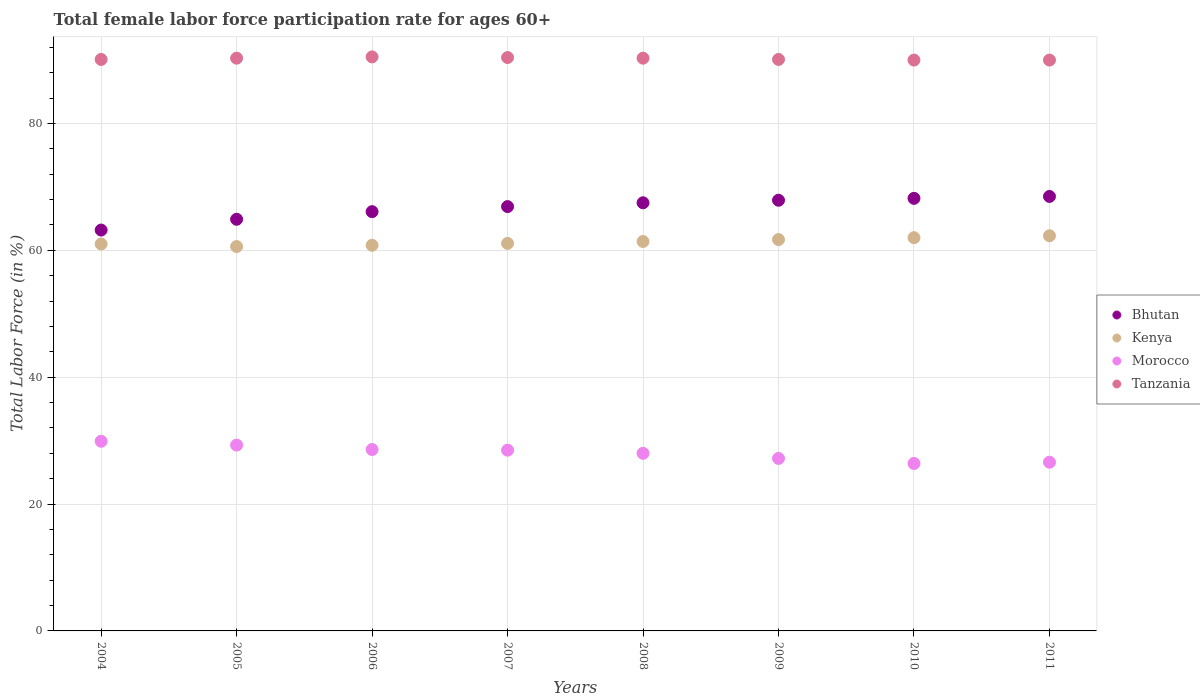Is the number of dotlines equal to the number of legend labels?
Your answer should be compact. Yes. What is the female labor force participation rate in Kenya in 2004?
Give a very brief answer. 61. Across all years, what is the maximum female labor force participation rate in Bhutan?
Offer a very short reply. 68.5. Across all years, what is the minimum female labor force participation rate in Bhutan?
Provide a succinct answer. 63.2. In which year was the female labor force participation rate in Tanzania minimum?
Provide a succinct answer. 2010. What is the total female labor force participation rate in Tanzania in the graph?
Your answer should be compact. 721.7. What is the difference between the female labor force participation rate in Bhutan in 2006 and that in 2010?
Keep it short and to the point. -2.1. What is the average female labor force participation rate in Bhutan per year?
Offer a terse response. 66.65. In the year 2007, what is the difference between the female labor force participation rate in Morocco and female labor force participation rate in Bhutan?
Your answer should be compact. -38.4. What is the ratio of the female labor force participation rate in Tanzania in 2004 to that in 2010?
Give a very brief answer. 1. Is the female labor force participation rate in Tanzania in 2009 less than that in 2010?
Ensure brevity in your answer.  No. What is the difference between the highest and the second highest female labor force participation rate in Bhutan?
Your answer should be very brief. 0.3. What is the difference between the highest and the lowest female labor force participation rate in Morocco?
Offer a terse response. 3.5. In how many years, is the female labor force participation rate in Tanzania greater than the average female labor force participation rate in Tanzania taken over all years?
Make the answer very short. 4. Is the sum of the female labor force participation rate in Bhutan in 2006 and 2011 greater than the maximum female labor force participation rate in Morocco across all years?
Your response must be concise. Yes. Does the female labor force participation rate in Kenya monotonically increase over the years?
Keep it short and to the point. No. Is the female labor force participation rate in Kenya strictly greater than the female labor force participation rate in Tanzania over the years?
Ensure brevity in your answer.  No. Is the female labor force participation rate in Tanzania strictly less than the female labor force participation rate in Morocco over the years?
Ensure brevity in your answer.  No. How many years are there in the graph?
Keep it short and to the point. 8. What is the difference between two consecutive major ticks on the Y-axis?
Provide a short and direct response. 20. Are the values on the major ticks of Y-axis written in scientific E-notation?
Provide a short and direct response. No. How are the legend labels stacked?
Your answer should be very brief. Vertical. What is the title of the graph?
Make the answer very short. Total female labor force participation rate for ages 60+. What is the label or title of the Y-axis?
Offer a very short reply. Total Labor Force (in %). What is the Total Labor Force (in %) of Bhutan in 2004?
Offer a terse response. 63.2. What is the Total Labor Force (in %) in Morocco in 2004?
Offer a very short reply. 29.9. What is the Total Labor Force (in %) in Tanzania in 2004?
Your answer should be compact. 90.1. What is the Total Labor Force (in %) of Bhutan in 2005?
Your response must be concise. 64.9. What is the Total Labor Force (in %) of Kenya in 2005?
Give a very brief answer. 60.6. What is the Total Labor Force (in %) of Morocco in 2005?
Keep it short and to the point. 29.3. What is the Total Labor Force (in %) of Tanzania in 2005?
Offer a terse response. 90.3. What is the Total Labor Force (in %) in Bhutan in 2006?
Your answer should be very brief. 66.1. What is the Total Labor Force (in %) in Kenya in 2006?
Ensure brevity in your answer.  60.8. What is the Total Labor Force (in %) of Morocco in 2006?
Keep it short and to the point. 28.6. What is the Total Labor Force (in %) in Tanzania in 2006?
Offer a very short reply. 90.5. What is the Total Labor Force (in %) in Bhutan in 2007?
Provide a short and direct response. 66.9. What is the Total Labor Force (in %) of Kenya in 2007?
Offer a terse response. 61.1. What is the Total Labor Force (in %) in Morocco in 2007?
Keep it short and to the point. 28.5. What is the Total Labor Force (in %) of Tanzania in 2007?
Ensure brevity in your answer.  90.4. What is the Total Labor Force (in %) of Bhutan in 2008?
Offer a very short reply. 67.5. What is the Total Labor Force (in %) of Kenya in 2008?
Your answer should be very brief. 61.4. What is the Total Labor Force (in %) in Tanzania in 2008?
Provide a succinct answer. 90.3. What is the Total Labor Force (in %) in Bhutan in 2009?
Ensure brevity in your answer.  67.9. What is the Total Labor Force (in %) of Kenya in 2009?
Provide a short and direct response. 61.7. What is the Total Labor Force (in %) in Morocco in 2009?
Your answer should be compact. 27.2. What is the Total Labor Force (in %) in Tanzania in 2009?
Provide a succinct answer. 90.1. What is the Total Labor Force (in %) in Bhutan in 2010?
Make the answer very short. 68.2. What is the Total Labor Force (in %) of Kenya in 2010?
Ensure brevity in your answer.  62. What is the Total Labor Force (in %) of Morocco in 2010?
Your response must be concise. 26.4. What is the Total Labor Force (in %) of Bhutan in 2011?
Offer a terse response. 68.5. What is the Total Labor Force (in %) of Kenya in 2011?
Your answer should be very brief. 62.3. What is the Total Labor Force (in %) of Morocco in 2011?
Offer a very short reply. 26.6. Across all years, what is the maximum Total Labor Force (in %) in Bhutan?
Provide a short and direct response. 68.5. Across all years, what is the maximum Total Labor Force (in %) of Kenya?
Your answer should be compact. 62.3. Across all years, what is the maximum Total Labor Force (in %) of Morocco?
Your answer should be compact. 29.9. Across all years, what is the maximum Total Labor Force (in %) of Tanzania?
Your answer should be compact. 90.5. Across all years, what is the minimum Total Labor Force (in %) of Bhutan?
Offer a terse response. 63.2. Across all years, what is the minimum Total Labor Force (in %) in Kenya?
Your response must be concise. 60.6. Across all years, what is the minimum Total Labor Force (in %) in Morocco?
Keep it short and to the point. 26.4. What is the total Total Labor Force (in %) of Bhutan in the graph?
Make the answer very short. 533.2. What is the total Total Labor Force (in %) in Kenya in the graph?
Offer a terse response. 490.9. What is the total Total Labor Force (in %) of Morocco in the graph?
Offer a terse response. 224.5. What is the total Total Labor Force (in %) in Tanzania in the graph?
Provide a short and direct response. 721.7. What is the difference between the Total Labor Force (in %) of Bhutan in 2004 and that in 2005?
Offer a very short reply. -1.7. What is the difference between the Total Labor Force (in %) of Bhutan in 2004 and that in 2006?
Offer a very short reply. -2.9. What is the difference between the Total Labor Force (in %) of Kenya in 2004 and that in 2007?
Make the answer very short. -0.1. What is the difference between the Total Labor Force (in %) in Tanzania in 2004 and that in 2007?
Provide a short and direct response. -0.3. What is the difference between the Total Labor Force (in %) of Kenya in 2004 and that in 2008?
Make the answer very short. -0.4. What is the difference between the Total Labor Force (in %) in Tanzania in 2004 and that in 2008?
Offer a terse response. -0.2. What is the difference between the Total Labor Force (in %) in Bhutan in 2004 and that in 2009?
Your response must be concise. -4.7. What is the difference between the Total Labor Force (in %) in Bhutan in 2004 and that in 2010?
Make the answer very short. -5. What is the difference between the Total Labor Force (in %) in Tanzania in 2004 and that in 2011?
Your answer should be compact. 0.1. What is the difference between the Total Labor Force (in %) of Kenya in 2005 and that in 2006?
Ensure brevity in your answer.  -0.2. What is the difference between the Total Labor Force (in %) in Tanzania in 2005 and that in 2006?
Keep it short and to the point. -0.2. What is the difference between the Total Labor Force (in %) in Kenya in 2005 and that in 2007?
Make the answer very short. -0.5. What is the difference between the Total Labor Force (in %) in Morocco in 2005 and that in 2007?
Provide a succinct answer. 0.8. What is the difference between the Total Labor Force (in %) of Tanzania in 2005 and that in 2007?
Provide a short and direct response. -0.1. What is the difference between the Total Labor Force (in %) in Kenya in 2005 and that in 2009?
Your answer should be compact. -1.1. What is the difference between the Total Labor Force (in %) in Morocco in 2005 and that in 2009?
Offer a very short reply. 2.1. What is the difference between the Total Labor Force (in %) in Bhutan in 2005 and that in 2010?
Keep it short and to the point. -3.3. What is the difference between the Total Labor Force (in %) of Tanzania in 2005 and that in 2010?
Provide a succinct answer. 0.3. What is the difference between the Total Labor Force (in %) in Morocco in 2005 and that in 2011?
Give a very brief answer. 2.7. What is the difference between the Total Labor Force (in %) in Tanzania in 2005 and that in 2011?
Keep it short and to the point. 0.3. What is the difference between the Total Labor Force (in %) of Morocco in 2006 and that in 2007?
Provide a succinct answer. 0.1. What is the difference between the Total Labor Force (in %) of Bhutan in 2006 and that in 2008?
Keep it short and to the point. -1.4. What is the difference between the Total Labor Force (in %) of Morocco in 2006 and that in 2008?
Your answer should be compact. 0.6. What is the difference between the Total Labor Force (in %) in Tanzania in 2006 and that in 2008?
Offer a terse response. 0.2. What is the difference between the Total Labor Force (in %) in Bhutan in 2006 and that in 2009?
Ensure brevity in your answer.  -1.8. What is the difference between the Total Labor Force (in %) in Kenya in 2006 and that in 2009?
Give a very brief answer. -0.9. What is the difference between the Total Labor Force (in %) of Tanzania in 2006 and that in 2009?
Ensure brevity in your answer.  0.4. What is the difference between the Total Labor Force (in %) of Bhutan in 2006 and that in 2010?
Ensure brevity in your answer.  -2.1. What is the difference between the Total Labor Force (in %) of Morocco in 2006 and that in 2010?
Offer a very short reply. 2.2. What is the difference between the Total Labor Force (in %) of Bhutan in 2006 and that in 2011?
Keep it short and to the point. -2.4. What is the difference between the Total Labor Force (in %) in Kenya in 2006 and that in 2011?
Your answer should be compact. -1.5. What is the difference between the Total Labor Force (in %) in Tanzania in 2006 and that in 2011?
Offer a terse response. 0.5. What is the difference between the Total Labor Force (in %) of Bhutan in 2007 and that in 2008?
Offer a very short reply. -0.6. What is the difference between the Total Labor Force (in %) in Kenya in 2007 and that in 2008?
Provide a short and direct response. -0.3. What is the difference between the Total Labor Force (in %) of Tanzania in 2007 and that in 2008?
Offer a terse response. 0.1. What is the difference between the Total Labor Force (in %) of Bhutan in 2007 and that in 2010?
Offer a very short reply. -1.3. What is the difference between the Total Labor Force (in %) in Kenya in 2007 and that in 2010?
Ensure brevity in your answer.  -0.9. What is the difference between the Total Labor Force (in %) of Morocco in 2007 and that in 2010?
Offer a terse response. 2.1. What is the difference between the Total Labor Force (in %) of Bhutan in 2007 and that in 2011?
Your answer should be very brief. -1.6. What is the difference between the Total Labor Force (in %) in Kenya in 2007 and that in 2011?
Make the answer very short. -1.2. What is the difference between the Total Labor Force (in %) in Morocco in 2007 and that in 2011?
Provide a short and direct response. 1.9. What is the difference between the Total Labor Force (in %) of Tanzania in 2007 and that in 2011?
Offer a terse response. 0.4. What is the difference between the Total Labor Force (in %) in Kenya in 2008 and that in 2009?
Keep it short and to the point. -0.3. What is the difference between the Total Labor Force (in %) in Tanzania in 2008 and that in 2009?
Offer a terse response. 0.2. What is the difference between the Total Labor Force (in %) in Bhutan in 2008 and that in 2010?
Keep it short and to the point. -0.7. What is the difference between the Total Labor Force (in %) of Morocco in 2008 and that in 2010?
Provide a succinct answer. 1.6. What is the difference between the Total Labor Force (in %) of Tanzania in 2008 and that in 2010?
Make the answer very short. 0.3. What is the difference between the Total Labor Force (in %) in Morocco in 2008 and that in 2011?
Your response must be concise. 1.4. What is the difference between the Total Labor Force (in %) in Bhutan in 2009 and that in 2010?
Provide a short and direct response. -0.3. What is the difference between the Total Labor Force (in %) of Kenya in 2009 and that in 2010?
Offer a terse response. -0.3. What is the difference between the Total Labor Force (in %) of Bhutan in 2009 and that in 2011?
Offer a very short reply. -0.6. What is the difference between the Total Labor Force (in %) of Kenya in 2009 and that in 2011?
Offer a terse response. -0.6. What is the difference between the Total Labor Force (in %) in Tanzania in 2009 and that in 2011?
Give a very brief answer. 0.1. What is the difference between the Total Labor Force (in %) of Bhutan in 2010 and that in 2011?
Provide a succinct answer. -0.3. What is the difference between the Total Labor Force (in %) in Morocco in 2010 and that in 2011?
Provide a short and direct response. -0.2. What is the difference between the Total Labor Force (in %) in Tanzania in 2010 and that in 2011?
Offer a very short reply. 0. What is the difference between the Total Labor Force (in %) of Bhutan in 2004 and the Total Labor Force (in %) of Kenya in 2005?
Your answer should be compact. 2.6. What is the difference between the Total Labor Force (in %) of Bhutan in 2004 and the Total Labor Force (in %) of Morocco in 2005?
Give a very brief answer. 33.9. What is the difference between the Total Labor Force (in %) of Bhutan in 2004 and the Total Labor Force (in %) of Tanzania in 2005?
Your response must be concise. -27.1. What is the difference between the Total Labor Force (in %) of Kenya in 2004 and the Total Labor Force (in %) of Morocco in 2005?
Your answer should be very brief. 31.7. What is the difference between the Total Labor Force (in %) in Kenya in 2004 and the Total Labor Force (in %) in Tanzania in 2005?
Offer a very short reply. -29.3. What is the difference between the Total Labor Force (in %) of Morocco in 2004 and the Total Labor Force (in %) of Tanzania in 2005?
Offer a terse response. -60.4. What is the difference between the Total Labor Force (in %) of Bhutan in 2004 and the Total Labor Force (in %) of Morocco in 2006?
Your answer should be very brief. 34.6. What is the difference between the Total Labor Force (in %) of Bhutan in 2004 and the Total Labor Force (in %) of Tanzania in 2006?
Your response must be concise. -27.3. What is the difference between the Total Labor Force (in %) in Kenya in 2004 and the Total Labor Force (in %) in Morocco in 2006?
Your answer should be very brief. 32.4. What is the difference between the Total Labor Force (in %) in Kenya in 2004 and the Total Labor Force (in %) in Tanzania in 2006?
Keep it short and to the point. -29.5. What is the difference between the Total Labor Force (in %) in Morocco in 2004 and the Total Labor Force (in %) in Tanzania in 2006?
Ensure brevity in your answer.  -60.6. What is the difference between the Total Labor Force (in %) of Bhutan in 2004 and the Total Labor Force (in %) of Morocco in 2007?
Provide a short and direct response. 34.7. What is the difference between the Total Labor Force (in %) in Bhutan in 2004 and the Total Labor Force (in %) in Tanzania in 2007?
Ensure brevity in your answer.  -27.2. What is the difference between the Total Labor Force (in %) in Kenya in 2004 and the Total Labor Force (in %) in Morocco in 2007?
Provide a short and direct response. 32.5. What is the difference between the Total Labor Force (in %) in Kenya in 2004 and the Total Labor Force (in %) in Tanzania in 2007?
Give a very brief answer. -29.4. What is the difference between the Total Labor Force (in %) in Morocco in 2004 and the Total Labor Force (in %) in Tanzania in 2007?
Keep it short and to the point. -60.5. What is the difference between the Total Labor Force (in %) of Bhutan in 2004 and the Total Labor Force (in %) of Kenya in 2008?
Make the answer very short. 1.8. What is the difference between the Total Labor Force (in %) of Bhutan in 2004 and the Total Labor Force (in %) of Morocco in 2008?
Keep it short and to the point. 35.2. What is the difference between the Total Labor Force (in %) of Bhutan in 2004 and the Total Labor Force (in %) of Tanzania in 2008?
Make the answer very short. -27.1. What is the difference between the Total Labor Force (in %) of Kenya in 2004 and the Total Labor Force (in %) of Tanzania in 2008?
Offer a terse response. -29.3. What is the difference between the Total Labor Force (in %) in Morocco in 2004 and the Total Labor Force (in %) in Tanzania in 2008?
Make the answer very short. -60.4. What is the difference between the Total Labor Force (in %) in Bhutan in 2004 and the Total Labor Force (in %) in Kenya in 2009?
Your answer should be very brief. 1.5. What is the difference between the Total Labor Force (in %) in Bhutan in 2004 and the Total Labor Force (in %) in Morocco in 2009?
Your answer should be compact. 36. What is the difference between the Total Labor Force (in %) in Bhutan in 2004 and the Total Labor Force (in %) in Tanzania in 2009?
Offer a terse response. -26.9. What is the difference between the Total Labor Force (in %) in Kenya in 2004 and the Total Labor Force (in %) in Morocco in 2009?
Your response must be concise. 33.8. What is the difference between the Total Labor Force (in %) of Kenya in 2004 and the Total Labor Force (in %) of Tanzania in 2009?
Provide a short and direct response. -29.1. What is the difference between the Total Labor Force (in %) in Morocco in 2004 and the Total Labor Force (in %) in Tanzania in 2009?
Your answer should be very brief. -60.2. What is the difference between the Total Labor Force (in %) in Bhutan in 2004 and the Total Labor Force (in %) in Kenya in 2010?
Offer a terse response. 1.2. What is the difference between the Total Labor Force (in %) of Bhutan in 2004 and the Total Labor Force (in %) of Morocco in 2010?
Your answer should be very brief. 36.8. What is the difference between the Total Labor Force (in %) in Bhutan in 2004 and the Total Labor Force (in %) in Tanzania in 2010?
Offer a very short reply. -26.8. What is the difference between the Total Labor Force (in %) in Kenya in 2004 and the Total Labor Force (in %) in Morocco in 2010?
Offer a terse response. 34.6. What is the difference between the Total Labor Force (in %) of Kenya in 2004 and the Total Labor Force (in %) of Tanzania in 2010?
Offer a terse response. -29. What is the difference between the Total Labor Force (in %) in Morocco in 2004 and the Total Labor Force (in %) in Tanzania in 2010?
Give a very brief answer. -60.1. What is the difference between the Total Labor Force (in %) of Bhutan in 2004 and the Total Labor Force (in %) of Morocco in 2011?
Make the answer very short. 36.6. What is the difference between the Total Labor Force (in %) of Bhutan in 2004 and the Total Labor Force (in %) of Tanzania in 2011?
Your answer should be very brief. -26.8. What is the difference between the Total Labor Force (in %) in Kenya in 2004 and the Total Labor Force (in %) in Morocco in 2011?
Give a very brief answer. 34.4. What is the difference between the Total Labor Force (in %) in Kenya in 2004 and the Total Labor Force (in %) in Tanzania in 2011?
Your answer should be very brief. -29. What is the difference between the Total Labor Force (in %) of Morocco in 2004 and the Total Labor Force (in %) of Tanzania in 2011?
Give a very brief answer. -60.1. What is the difference between the Total Labor Force (in %) in Bhutan in 2005 and the Total Labor Force (in %) in Kenya in 2006?
Make the answer very short. 4.1. What is the difference between the Total Labor Force (in %) in Bhutan in 2005 and the Total Labor Force (in %) in Morocco in 2006?
Your answer should be very brief. 36.3. What is the difference between the Total Labor Force (in %) of Bhutan in 2005 and the Total Labor Force (in %) of Tanzania in 2006?
Offer a terse response. -25.6. What is the difference between the Total Labor Force (in %) in Kenya in 2005 and the Total Labor Force (in %) in Tanzania in 2006?
Your answer should be compact. -29.9. What is the difference between the Total Labor Force (in %) of Morocco in 2005 and the Total Labor Force (in %) of Tanzania in 2006?
Keep it short and to the point. -61.2. What is the difference between the Total Labor Force (in %) of Bhutan in 2005 and the Total Labor Force (in %) of Kenya in 2007?
Ensure brevity in your answer.  3.8. What is the difference between the Total Labor Force (in %) in Bhutan in 2005 and the Total Labor Force (in %) in Morocco in 2007?
Give a very brief answer. 36.4. What is the difference between the Total Labor Force (in %) of Bhutan in 2005 and the Total Labor Force (in %) of Tanzania in 2007?
Your answer should be very brief. -25.5. What is the difference between the Total Labor Force (in %) of Kenya in 2005 and the Total Labor Force (in %) of Morocco in 2007?
Make the answer very short. 32.1. What is the difference between the Total Labor Force (in %) of Kenya in 2005 and the Total Labor Force (in %) of Tanzania in 2007?
Offer a terse response. -29.8. What is the difference between the Total Labor Force (in %) in Morocco in 2005 and the Total Labor Force (in %) in Tanzania in 2007?
Offer a very short reply. -61.1. What is the difference between the Total Labor Force (in %) of Bhutan in 2005 and the Total Labor Force (in %) of Morocco in 2008?
Your answer should be very brief. 36.9. What is the difference between the Total Labor Force (in %) of Bhutan in 2005 and the Total Labor Force (in %) of Tanzania in 2008?
Your answer should be very brief. -25.4. What is the difference between the Total Labor Force (in %) in Kenya in 2005 and the Total Labor Force (in %) in Morocco in 2008?
Make the answer very short. 32.6. What is the difference between the Total Labor Force (in %) in Kenya in 2005 and the Total Labor Force (in %) in Tanzania in 2008?
Offer a terse response. -29.7. What is the difference between the Total Labor Force (in %) of Morocco in 2005 and the Total Labor Force (in %) of Tanzania in 2008?
Your answer should be very brief. -61. What is the difference between the Total Labor Force (in %) of Bhutan in 2005 and the Total Labor Force (in %) of Kenya in 2009?
Offer a very short reply. 3.2. What is the difference between the Total Labor Force (in %) in Bhutan in 2005 and the Total Labor Force (in %) in Morocco in 2009?
Offer a very short reply. 37.7. What is the difference between the Total Labor Force (in %) of Bhutan in 2005 and the Total Labor Force (in %) of Tanzania in 2009?
Your response must be concise. -25.2. What is the difference between the Total Labor Force (in %) in Kenya in 2005 and the Total Labor Force (in %) in Morocco in 2009?
Provide a short and direct response. 33.4. What is the difference between the Total Labor Force (in %) of Kenya in 2005 and the Total Labor Force (in %) of Tanzania in 2009?
Offer a terse response. -29.5. What is the difference between the Total Labor Force (in %) of Morocco in 2005 and the Total Labor Force (in %) of Tanzania in 2009?
Make the answer very short. -60.8. What is the difference between the Total Labor Force (in %) of Bhutan in 2005 and the Total Labor Force (in %) of Kenya in 2010?
Offer a very short reply. 2.9. What is the difference between the Total Labor Force (in %) of Bhutan in 2005 and the Total Labor Force (in %) of Morocco in 2010?
Your answer should be very brief. 38.5. What is the difference between the Total Labor Force (in %) in Bhutan in 2005 and the Total Labor Force (in %) in Tanzania in 2010?
Make the answer very short. -25.1. What is the difference between the Total Labor Force (in %) in Kenya in 2005 and the Total Labor Force (in %) in Morocco in 2010?
Make the answer very short. 34.2. What is the difference between the Total Labor Force (in %) of Kenya in 2005 and the Total Labor Force (in %) of Tanzania in 2010?
Make the answer very short. -29.4. What is the difference between the Total Labor Force (in %) of Morocco in 2005 and the Total Labor Force (in %) of Tanzania in 2010?
Ensure brevity in your answer.  -60.7. What is the difference between the Total Labor Force (in %) of Bhutan in 2005 and the Total Labor Force (in %) of Morocco in 2011?
Your answer should be compact. 38.3. What is the difference between the Total Labor Force (in %) of Bhutan in 2005 and the Total Labor Force (in %) of Tanzania in 2011?
Offer a very short reply. -25.1. What is the difference between the Total Labor Force (in %) in Kenya in 2005 and the Total Labor Force (in %) in Morocco in 2011?
Give a very brief answer. 34. What is the difference between the Total Labor Force (in %) in Kenya in 2005 and the Total Labor Force (in %) in Tanzania in 2011?
Make the answer very short. -29.4. What is the difference between the Total Labor Force (in %) in Morocco in 2005 and the Total Labor Force (in %) in Tanzania in 2011?
Keep it short and to the point. -60.7. What is the difference between the Total Labor Force (in %) in Bhutan in 2006 and the Total Labor Force (in %) in Morocco in 2007?
Offer a very short reply. 37.6. What is the difference between the Total Labor Force (in %) of Bhutan in 2006 and the Total Labor Force (in %) of Tanzania in 2007?
Offer a very short reply. -24.3. What is the difference between the Total Labor Force (in %) of Kenya in 2006 and the Total Labor Force (in %) of Morocco in 2007?
Offer a very short reply. 32.3. What is the difference between the Total Labor Force (in %) of Kenya in 2006 and the Total Labor Force (in %) of Tanzania in 2007?
Give a very brief answer. -29.6. What is the difference between the Total Labor Force (in %) in Morocco in 2006 and the Total Labor Force (in %) in Tanzania in 2007?
Make the answer very short. -61.8. What is the difference between the Total Labor Force (in %) of Bhutan in 2006 and the Total Labor Force (in %) of Morocco in 2008?
Your response must be concise. 38.1. What is the difference between the Total Labor Force (in %) in Bhutan in 2006 and the Total Labor Force (in %) in Tanzania in 2008?
Keep it short and to the point. -24.2. What is the difference between the Total Labor Force (in %) of Kenya in 2006 and the Total Labor Force (in %) of Morocco in 2008?
Keep it short and to the point. 32.8. What is the difference between the Total Labor Force (in %) of Kenya in 2006 and the Total Labor Force (in %) of Tanzania in 2008?
Offer a very short reply. -29.5. What is the difference between the Total Labor Force (in %) of Morocco in 2006 and the Total Labor Force (in %) of Tanzania in 2008?
Provide a succinct answer. -61.7. What is the difference between the Total Labor Force (in %) in Bhutan in 2006 and the Total Labor Force (in %) in Kenya in 2009?
Make the answer very short. 4.4. What is the difference between the Total Labor Force (in %) of Bhutan in 2006 and the Total Labor Force (in %) of Morocco in 2009?
Ensure brevity in your answer.  38.9. What is the difference between the Total Labor Force (in %) of Kenya in 2006 and the Total Labor Force (in %) of Morocco in 2009?
Keep it short and to the point. 33.6. What is the difference between the Total Labor Force (in %) of Kenya in 2006 and the Total Labor Force (in %) of Tanzania in 2009?
Your response must be concise. -29.3. What is the difference between the Total Labor Force (in %) in Morocco in 2006 and the Total Labor Force (in %) in Tanzania in 2009?
Your answer should be compact. -61.5. What is the difference between the Total Labor Force (in %) in Bhutan in 2006 and the Total Labor Force (in %) in Morocco in 2010?
Make the answer very short. 39.7. What is the difference between the Total Labor Force (in %) in Bhutan in 2006 and the Total Labor Force (in %) in Tanzania in 2010?
Keep it short and to the point. -23.9. What is the difference between the Total Labor Force (in %) in Kenya in 2006 and the Total Labor Force (in %) in Morocco in 2010?
Provide a succinct answer. 34.4. What is the difference between the Total Labor Force (in %) in Kenya in 2006 and the Total Labor Force (in %) in Tanzania in 2010?
Offer a very short reply. -29.2. What is the difference between the Total Labor Force (in %) of Morocco in 2006 and the Total Labor Force (in %) of Tanzania in 2010?
Your response must be concise. -61.4. What is the difference between the Total Labor Force (in %) of Bhutan in 2006 and the Total Labor Force (in %) of Kenya in 2011?
Offer a terse response. 3.8. What is the difference between the Total Labor Force (in %) of Bhutan in 2006 and the Total Labor Force (in %) of Morocco in 2011?
Offer a terse response. 39.5. What is the difference between the Total Labor Force (in %) in Bhutan in 2006 and the Total Labor Force (in %) in Tanzania in 2011?
Your answer should be very brief. -23.9. What is the difference between the Total Labor Force (in %) in Kenya in 2006 and the Total Labor Force (in %) in Morocco in 2011?
Provide a short and direct response. 34.2. What is the difference between the Total Labor Force (in %) in Kenya in 2006 and the Total Labor Force (in %) in Tanzania in 2011?
Make the answer very short. -29.2. What is the difference between the Total Labor Force (in %) in Morocco in 2006 and the Total Labor Force (in %) in Tanzania in 2011?
Offer a terse response. -61.4. What is the difference between the Total Labor Force (in %) in Bhutan in 2007 and the Total Labor Force (in %) in Morocco in 2008?
Your answer should be compact. 38.9. What is the difference between the Total Labor Force (in %) of Bhutan in 2007 and the Total Labor Force (in %) of Tanzania in 2008?
Your response must be concise. -23.4. What is the difference between the Total Labor Force (in %) of Kenya in 2007 and the Total Labor Force (in %) of Morocco in 2008?
Provide a short and direct response. 33.1. What is the difference between the Total Labor Force (in %) of Kenya in 2007 and the Total Labor Force (in %) of Tanzania in 2008?
Your response must be concise. -29.2. What is the difference between the Total Labor Force (in %) in Morocco in 2007 and the Total Labor Force (in %) in Tanzania in 2008?
Your answer should be very brief. -61.8. What is the difference between the Total Labor Force (in %) in Bhutan in 2007 and the Total Labor Force (in %) in Morocco in 2009?
Your response must be concise. 39.7. What is the difference between the Total Labor Force (in %) in Bhutan in 2007 and the Total Labor Force (in %) in Tanzania in 2009?
Keep it short and to the point. -23.2. What is the difference between the Total Labor Force (in %) in Kenya in 2007 and the Total Labor Force (in %) in Morocco in 2009?
Your answer should be compact. 33.9. What is the difference between the Total Labor Force (in %) in Kenya in 2007 and the Total Labor Force (in %) in Tanzania in 2009?
Provide a short and direct response. -29. What is the difference between the Total Labor Force (in %) of Morocco in 2007 and the Total Labor Force (in %) of Tanzania in 2009?
Give a very brief answer. -61.6. What is the difference between the Total Labor Force (in %) of Bhutan in 2007 and the Total Labor Force (in %) of Morocco in 2010?
Give a very brief answer. 40.5. What is the difference between the Total Labor Force (in %) in Bhutan in 2007 and the Total Labor Force (in %) in Tanzania in 2010?
Your answer should be very brief. -23.1. What is the difference between the Total Labor Force (in %) of Kenya in 2007 and the Total Labor Force (in %) of Morocco in 2010?
Make the answer very short. 34.7. What is the difference between the Total Labor Force (in %) of Kenya in 2007 and the Total Labor Force (in %) of Tanzania in 2010?
Your answer should be very brief. -28.9. What is the difference between the Total Labor Force (in %) of Morocco in 2007 and the Total Labor Force (in %) of Tanzania in 2010?
Your answer should be very brief. -61.5. What is the difference between the Total Labor Force (in %) in Bhutan in 2007 and the Total Labor Force (in %) in Kenya in 2011?
Your answer should be very brief. 4.6. What is the difference between the Total Labor Force (in %) in Bhutan in 2007 and the Total Labor Force (in %) in Morocco in 2011?
Provide a succinct answer. 40.3. What is the difference between the Total Labor Force (in %) of Bhutan in 2007 and the Total Labor Force (in %) of Tanzania in 2011?
Your response must be concise. -23.1. What is the difference between the Total Labor Force (in %) of Kenya in 2007 and the Total Labor Force (in %) of Morocco in 2011?
Offer a terse response. 34.5. What is the difference between the Total Labor Force (in %) in Kenya in 2007 and the Total Labor Force (in %) in Tanzania in 2011?
Provide a succinct answer. -28.9. What is the difference between the Total Labor Force (in %) in Morocco in 2007 and the Total Labor Force (in %) in Tanzania in 2011?
Your answer should be compact. -61.5. What is the difference between the Total Labor Force (in %) in Bhutan in 2008 and the Total Labor Force (in %) in Kenya in 2009?
Make the answer very short. 5.8. What is the difference between the Total Labor Force (in %) in Bhutan in 2008 and the Total Labor Force (in %) in Morocco in 2009?
Offer a terse response. 40.3. What is the difference between the Total Labor Force (in %) in Bhutan in 2008 and the Total Labor Force (in %) in Tanzania in 2009?
Offer a very short reply. -22.6. What is the difference between the Total Labor Force (in %) of Kenya in 2008 and the Total Labor Force (in %) of Morocco in 2009?
Offer a very short reply. 34.2. What is the difference between the Total Labor Force (in %) of Kenya in 2008 and the Total Labor Force (in %) of Tanzania in 2009?
Your response must be concise. -28.7. What is the difference between the Total Labor Force (in %) in Morocco in 2008 and the Total Labor Force (in %) in Tanzania in 2009?
Provide a succinct answer. -62.1. What is the difference between the Total Labor Force (in %) in Bhutan in 2008 and the Total Labor Force (in %) in Morocco in 2010?
Your answer should be very brief. 41.1. What is the difference between the Total Labor Force (in %) in Bhutan in 2008 and the Total Labor Force (in %) in Tanzania in 2010?
Your response must be concise. -22.5. What is the difference between the Total Labor Force (in %) of Kenya in 2008 and the Total Labor Force (in %) of Morocco in 2010?
Ensure brevity in your answer.  35. What is the difference between the Total Labor Force (in %) of Kenya in 2008 and the Total Labor Force (in %) of Tanzania in 2010?
Give a very brief answer. -28.6. What is the difference between the Total Labor Force (in %) of Morocco in 2008 and the Total Labor Force (in %) of Tanzania in 2010?
Your response must be concise. -62. What is the difference between the Total Labor Force (in %) of Bhutan in 2008 and the Total Labor Force (in %) of Morocco in 2011?
Provide a succinct answer. 40.9. What is the difference between the Total Labor Force (in %) of Bhutan in 2008 and the Total Labor Force (in %) of Tanzania in 2011?
Provide a succinct answer. -22.5. What is the difference between the Total Labor Force (in %) of Kenya in 2008 and the Total Labor Force (in %) of Morocco in 2011?
Give a very brief answer. 34.8. What is the difference between the Total Labor Force (in %) of Kenya in 2008 and the Total Labor Force (in %) of Tanzania in 2011?
Ensure brevity in your answer.  -28.6. What is the difference between the Total Labor Force (in %) in Morocco in 2008 and the Total Labor Force (in %) in Tanzania in 2011?
Offer a very short reply. -62. What is the difference between the Total Labor Force (in %) of Bhutan in 2009 and the Total Labor Force (in %) of Morocco in 2010?
Give a very brief answer. 41.5. What is the difference between the Total Labor Force (in %) of Bhutan in 2009 and the Total Labor Force (in %) of Tanzania in 2010?
Keep it short and to the point. -22.1. What is the difference between the Total Labor Force (in %) in Kenya in 2009 and the Total Labor Force (in %) in Morocco in 2010?
Provide a succinct answer. 35.3. What is the difference between the Total Labor Force (in %) of Kenya in 2009 and the Total Labor Force (in %) of Tanzania in 2010?
Provide a short and direct response. -28.3. What is the difference between the Total Labor Force (in %) in Morocco in 2009 and the Total Labor Force (in %) in Tanzania in 2010?
Offer a terse response. -62.8. What is the difference between the Total Labor Force (in %) in Bhutan in 2009 and the Total Labor Force (in %) in Kenya in 2011?
Provide a short and direct response. 5.6. What is the difference between the Total Labor Force (in %) in Bhutan in 2009 and the Total Labor Force (in %) in Morocco in 2011?
Give a very brief answer. 41.3. What is the difference between the Total Labor Force (in %) in Bhutan in 2009 and the Total Labor Force (in %) in Tanzania in 2011?
Make the answer very short. -22.1. What is the difference between the Total Labor Force (in %) in Kenya in 2009 and the Total Labor Force (in %) in Morocco in 2011?
Offer a terse response. 35.1. What is the difference between the Total Labor Force (in %) of Kenya in 2009 and the Total Labor Force (in %) of Tanzania in 2011?
Keep it short and to the point. -28.3. What is the difference between the Total Labor Force (in %) in Morocco in 2009 and the Total Labor Force (in %) in Tanzania in 2011?
Provide a succinct answer. -62.8. What is the difference between the Total Labor Force (in %) in Bhutan in 2010 and the Total Labor Force (in %) in Morocco in 2011?
Keep it short and to the point. 41.6. What is the difference between the Total Labor Force (in %) of Bhutan in 2010 and the Total Labor Force (in %) of Tanzania in 2011?
Your answer should be compact. -21.8. What is the difference between the Total Labor Force (in %) in Kenya in 2010 and the Total Labor Force (in %) in Morocco in 2011?
Offer a very short reply. 35.4. What is the difference between the Total Labor Force (in %) of Kenya in 2010 and the Total Labor Force (in %) of Tanzania in 2011?
Your response must be concise. -28. What is the difference between the Total Labor Force (in %) of Morocco in 2010 and the Total Labor Force (in %) of Tanzania in 2011?
Your answer should be compact. -63.6. What is the average Total Labor Force (in %) of Bhutan per year?
Ensure brevity in your answer.  66.65. What is the average Total Labor Force (in %) of Kenya per year?
Provide a succinct answer. 61.36. What is the average Total Labor Force (in %) in Morocco per year?
Provide a short and direct response. 28.06. What is the average Total Labor Force (in %) in Tanzania per year?
Keep it short and to the point. 90.21. In the year 2004, what is the difference between the Total Labor Force (in %) of Bhutan and Total Labor Force (in %) of Morocco?
Your answer should be very brief. 33.3. In the year 2004, what is the difference between the Total Labor Force (in %) in Bhutan and Total Labor Force (in %) in Tanzania?
Your answer should be compact. -26.9. In the year 2004, what is the difference between the Total Labor Force (in %) of Kenya and Total Labor Force (in %) of Morocco?
Provide a short and direct response. 31.1. In the year 2004, what is the difference between the Total Labor Force (in %) of Kenya and Total Labor Force (in %) of Tanzania?
Provide a succinct answer. -29.1. In the year 2004, what is the difference between the Total Labor Force (in %) in Morocco and Total Labor Force (in %) in Tanzania?
Your answer should be compact. -60.2. In the year 2005, what is the difference between the Total Labor Force (in %) in Bhutan and Total Labor Force (in %) in Kenya?
Make the answer very short. 4.3. In the year 2005, what is the difference between the Total Labor Force (in %) in Bhutan and Total Labor Force (in %) in Morocco?
Make the answer very short. 35.6. In the year 2005, what is the difference between the Total Labor Force (in %) of Bhutan and Total Labor Force (in %) of Tanzania?
Provide a short and direct response. -25.4. In the year 2005, what is the difference between the Total Labor Force (in %) of Kenya and Total Labor Force (in %) of Morocco?
Keep it short and to the point. 31.3. In the year 2005, what is the difference between the Total Labor Force (in %) of Kenya and Total Labor Force (in %) of Tanzania?
Provide a succinct answer. -29.7. In the year 2005, what is the difference between the Total Labor Force (in %) of Morocco and Total Labor Force (in %) of Tanzania?
Your answer should be compact. -61. In the year 2006, what is the difference between the Total Labor Force (in %) of Bhutan and Total Labor Force (in %) of Kenya?
Your answer should be compact. 5.3. In the year 2006, what is the difference between the Total Labor Force (in %) in Bhutan and Total Labor Force (in %) in Morocco?
Offer a very short reply. 37.5. In the year 2006, what is the difference between the Total Labor Force (in %) in Bhutan and Total Labor Force (in %) in Tanzania?
Provide a succinct answer. -24.4. In the year 2006, what is the difference between the Total Labor Force (in %) in Kenya and Total Labor Force (in %) in Morocco?
Ensure brevity in your answer.  32.2. In the year 2006, what is the difference between the Total Labor Force (in %) of Kenya and Total Labor Force (in %) of Tanzania?
Offer a very short reply. -29.7. In the year 2006, what is the difference between the Total Labor Force (in %) in Morocco and Total Labor Force (in %) in Tanzania?
Your response must be concise. -61.9. In the year 2007, what is the difference between the Total Labor Force (in %) of Bhutan and Total Labor Force (in %) of Morocco?
Your answer should be compact. 38.4. In the year 2007, what is the difference between the Total Labor Force (in %) of Bhutan and Total Labor Force (in %) of Tanzania?
Give a very brief answer. -23.5. In the year 2007, what is the difference between the Total Labor Force (in %) in Kenya and Total Labor Force (in %) in Morocco?
Offer a very short reply. 32.6. In the year 2007, what is the difference between the Total Labor Force (in %) of Kenya and Total Labor Force (in %) of Tanzania?
Your answer should be very brief. -29.3. In the year 2007, what is the difference between the Total Labor Force (in %) in Morocco and Total Labor Force (in %) in Tanzania?
Give a very brief answer. -61.9. In the year 2008, what is the difference between the Total Labor Force (in %) of Bhutan and Total Labor Force (in %) of Kenya?
Provide a succinct answer. 6.1. In the year 2008, what is the difference between the Total Labor Force (in %) of Bhutan and Total Labor Force (in %) of Morocco?
Provide a succinct answer. 39.5. In the year 2008, what is the difference between the Total Labor Force (in %) in Bhutan and Total Labor Force (in %) in Tanzania?
Your answer should be compact. -22.8. In the year 2008, what is the difference between the Total Labor Force (in %) in Kenya and Total Labor Force (in %) in Morocco?
Provide a short and direct response. 33.4. In the year 2008, what is the difference between the Total Labor Force (in %) in Kenya and Total Labor Force (in %) in Tanzania?
Your answer should be very brief. -28.9. In the year 2008, what is the difference between the Total Labor Force (in %) of Morocco and Total Labor Force (in %) of Tanzania?
Make the answer very short. -62.3. In the year 2009, what is the difference between the Total Labor Force (in %) in Bhutan and Total Labor Force (in %) in Kenya?
Make the answer very short. 6.2. In the year 2009, what is the difference between the Total Labor Force (in %) in Bhutan and Total Labor Force (in %) in Morocco?
Keep it short and to the point. 40.7. In the year 2009, what is the difference between the Total Labor Force (in %) of Bhutan and Total Labor Force (in %) of Tanzania?
Make the answer very short. -22.2. In the year 2009, what is the difference between the Total Labor Force (in %) in Kenya and Total Labor Force (in %) in Morocco?
Provide a succinct answer. 34.5. In the year 2009, what is the difference between the Total Labor Force (in %) in Kenya and Total Labor Force (in %) in Tanzania?
Provide a succinct answer. -28.4. In the year 2009, what is the difference between the Total Labor Force (in %) of Morocco and Total Labor Force (in %) of Tanzania?
Ensure brevity in your answer.  -62.9. In the year 2010, what is the difference between the Total Labor Force (in %) of Bhutan and Total Labor Force (in %) of Morocco?
Provide a short and direct response. 41.8. In the year 2010, what is the difference between the Total Labor Force (in %) in Bhutan and Total Labor Force (in %) in Tanzania?
Keep it short and to the point. -21.8. In the year 2010, what is the difference between the Total Labor Force (in %) in Kenya and Total Labor Force (in %) in Morocco?
Make the answer very short. 35.6. In the year 2010, what is the difference between the Total Labor Force (in %) in Morocco and Total Labor Force (in %) in Tanzania?
Your response must be concise. -63.6. In the year 2011, what is the difference between the Total Labor Force (in %) of Bhutan and Total Labor Force (in %) of Kenya?
Keep it short and to the point. 6.2. In the year 2011, what is the difference between the Total Labor Force (in %) in Bhutan and Total Labor Force (in %) in Morocco?
Ensure brevity in your answer.  41.9. In the year 2011, what is the difference between the Total Labor Force (in %) in Bhutan and Total Labor Force (in %) in Tanzania?
Keep it short and to the point. -21.5. In the year 2011, what is the difference between the Total Labor Force (in %) of Kenya and Total Labor Force (in %) of Morocco?
Provide a short and direct response. 35.7. In the year 2011, what is the difference between the Total Labor Force (in %) of Kenya and Total Labor Force (in %) of Tanzania?
Your answer should be very brief. -27.7. In the year 2011, what is the difference between the Total Labor Force (in %) of Morocco and Total Labor Force (in %) of Tanzania?
Keep it short and to the point. -63.4. What is the ratio of the Total Labor Force (in %) of Bhutan in 2004 to that in 2005?
Offer a very short reply. 0.97. What is the ratio of the Total Labor Force (in %) in Kenya in 2004 to that in 2005?
Offer a terse response. 1.01. What is the ratio of the Total Labor Force (in %) of Morocco in 2004 to that in 2005?
Offer a very short reply. 1.02. What is the ratio of the Total Labor Force (in %) in Bhutan in 2004 to that in 2006?
Provide a short and direct response. 0.96. What is the ratio of the Total Labor Force (in %) of Kenya in 2004 to that in 2006?
Provide a succinct answer. 1. What is the ratio of the Total Labor Force (in %) of Morocco in 2004 to that in 2006?
Make the answer very short. 1.05. What is the ratio of the Total Labor Force (in %) in Tanzania in 2004 to that in 2006?
Offer a terse response. 1. What is the ratio of the Total Labor Force (in %) of Bhutan in 2004 to that in 2007?
Your answer should be very brief. 0.94. What is the ratio of the Total Labor Force (in %) in Morocco in 2004 to that in 2007?
Make the answer very short. 1.05. What is the ratio of the Total Labor Force (in %) of Bhutan in 2004 to that in 2008?
Give a very brief answer. 0.94. What is the ratio of the Total Labor Force (in %) of Kenya in 2004 to that in 2008?
Give a very brief answer. 0.99. What is the ratio of the Total Labor Force (in %) of Morocco in 2004 to that in 2008?
Ensure brevity in your answer.  1.07. What is the ratio of the Total Labor Force (in %) of Tanzania in 2004 to that in 2008?
Make the answer very short. 1. What is the ratio of the Total Labor Force (in %) in Bhutan in 2004 to that in 2009?
Your answer should be very brief. 0.93. What is the ratio of the Total Labor Force (in %) of Kenya in 2004 to that in 2009?
Ensure brevity in your answer.  0.99. What is the ratio of the Total Labor Force (in %) in Morocco in 2004 to that in 2009?
Provide a short and direct response. 1.1. What is the ratio of the Total Labor Force (in %) in Bhutan in 2004 to that in 2010?
Provide a succinct answer. 0.93. What is the ratio of the Total Labor Force (in %) of Kenya in 2004 to that in 2010?
Provide a short and direct response. 0.98. What is the ratio of the Total Labor Force (in %) in Morocco in 2004 to that in 2010?
Offer a very short reply. 1.13. What is the ratio of the Total Labor Force (in %) of Bhutan in 2004 to that in 2011?
Give a very brief answer. 0.92. What is the ratio of the Total Labor Force (in %) in Kenya in 2004 to that in 2011?
Provide a succinct answer. 0.98. What is the ratio of the Total Labor Force (in %) in Morocco in 2004 to that in 2011?
Your answer should be compact. 1.12. What is the ratio of the Total Labor Force (in %) in Bhutan in 2005 to that in 2006?
Make the answer very short. 0.98. What is the ratio of the Total Labor Force (in %) in Kenya in 2005 to that in 2006?
Your answer should be compact. 1. What is the ratio of the Total Labor Force (in %) in Morocco in 2005 to that in 2006?
Give a very brief answer. 1.02. What is the ratio of the Total Labor Force (in %) in Tanzania in 2005 to that in 2006?
Ensure brevity in your answer.  1. What is the ratio of the Total Labor Force (in %) of Bhutan in 2005 to that in 2007?
Give a very brief answer. 0.97. What is the ratio of the Total Labor Force (in %) of Kenya in 2005 to that in 2007?
Ensure brevity in your answer.  0.99. What is the ratio of the Total Labor Force (in %) of Morocco in 2005 to that in 2007?
Offer a terse response. 1.03. What is the ratio of the Total Labor Force (in %) in Bhutan in 2005 to that in 2008?
Keep it short and to the point. 0.96. What is the ratio of the Total Labor Force (in %) of Kenya in 2005 to that in 2008?
Offer a terse response. 0.99. What is the ratio of the Total Labor Force (in %) of Morocco in 2005 to that in 2008?
Offer a very short reply. 1.05. What is the ratio of the Total Labor Force (in %) of Bhutan in 2005 to that in 2009?
Provide a succinct answer. 0.96. What is the ratio of the Total Labor Force (in %) of Kenya in 2005 to that in 2009?
Give a very brief answer. 0.98. What is the ratio of the Total Labor Force (in %) of Morocco in 2005 to that in 2009?
Your response must be concise. 1.08. What is the ratio of the Total Labor Force (in %) of Tanzania in 2005 to that in 2009?
Provide a succinct answer. 1. What is the ratio of the Total Labor Force (in %) of Bhutan in 2005 to that in 2010?
Provide a succinct answer. 0.95. What is the ratio of the Total Labor Force (in %) in Kenya in 2005 to that in 2010?
Give a very brief answer. 0.98. What is the ratio of the Total Labor Force (in %) in Morocco in 2005 to that in 2010?
Your answer should be very brief. 1.11. What is the ratio of the Total Labor Force (in %) in Kenya in 2005 to that in 2011?
Provide a short and direct response. 0.97. What is the ratio of the Total Labor Force (in %) of Morocco in 2005 to that in 2011?
Make the answer very short. 1.1. What is the ratio of the Total Labor Force (in %) of Tanzania in 2005 to that in 2011?
Offer a very short reply. 1. What is the ratio of the Total Labor Force (in %) of Bhutan in 2006 to that in 2007?
Ensure brevity in your answer.  0.99. What is the ratio of the Total Labor Force (in %) of Kenya in 2006 to that in 2007?
Make the answer very short. 1. What is the ratio of the Total Labor Force (in %) in Tanzania in 2006 to that in 2007?
Offer a terse response. 1. What is the ratio of the Total Labor Force (in %) of Bhutan in 2006 to that in 2008?
Provide a short and direct response. 0.98. What is the ratio of the Total Labor Force (in %) in Kenya in 2006 to that in 2008?
Make the answer very short. 0.99. What is the ratio of the Total Labor Force (in %) in Morocco in 2006 to that in 2008?
Give a very brief answer. 1.02. What is the ratio of the Total Labor Force (in %) in Tanzania in 2006 to that in 2008?
Provide a succinct answer. 1. What is the ratio of the Total Labor Force (in %) of Bhutan in 2006 to that in 2009?
Keep it short and to the point. 0.97. What is the ratio of the Total Labor Force (in %) of Kenya in 2006 to that in 2009?
Keep it short and to the point. 0.99. What is the ratio of the Total Labor Force (in %) in Morocco in 2006 to that in 2009?
Provide a succinct answer. 1.05. What is the ratio of the Total Labor Force (in %) in Bhutan in 2006 to that in 2010?
Your answer should be compact. 0.97. What is the ratio of the Total Labor Force (in %) in Kenya in 2006 to that in 2010?
Provide a short and direct response. 0.98. What is the ratio of the Total Labor Force (in %) in Morocco in 2006 to that in 2010?
Your answer should be very brief. 1.08. What is the ratio of the Total Labor Force (in %) in Tanzania in 2006 to that in 2010?
Provide a short and direct response. 1.01. What is the ratio of the Total Labor Force (in %) in Bhutan in 2006 to that in 2011?
Offer a very short reply. 0.96. What is the ratio of the Total Labor Force (in %) in Kenya in 2006 to that in 2011?
Offer a very short reply. 0.98. What is the ratio of the Total Labor Force (in %) of Morocco in 2006 to that in 2011?
Your answer should be very brief. 1.08. What is the ratio of the Total Labor Force (in %) of Tanzania in 2006 to that in 2011?
Keep it short and to the point. 1.01. What is the ratio of the Total Labor Force (in %) of Morocco in 2007 to that in 2008?
Make the answer very short. 1.02. What is the ratio of the Total Labor Force (in %) of Tanzania in 2007 to that in 2008?
Make the answer very short. 1. What is the ratio of the Total Labor Force (in %) in Kenya in 2007 to that in 2009?
Offer a terse response. 0.99. What is the ratio of the Total Labor Force (in %) of Morocco in 2007 to that in 2009?
Offer a very short reply. 1.05. What is the ratio of the Total Labor Force (in %) of Tanzania in 2007 to that in 2009?
Offer a very short reply. 1. What is the ratio of the Total Labor Force (in %) in Bhutan in 2007 to that in 2010?
Keep it short and to the point. 0.98. What is the ratio of the Total Labor Force (in %) in Kenya in 2007 to that in 2010?
Your answer should be very brief. 0.99. What is the ratio of the Total Labor Force (in %) of Morocco in 2007 to that in 2010?
Make the answer very short. 1.08. What is the ratio of the Total Labor Force (in %) in Bhutan in 2007 to that in 2011?
Ensure brevity in your answer.  0.98. What is the ratio of the Total Labor Force (in %) in Kenya in 2007 to that in 2011?
Offer a terse response. 0.98. What is the ratio of the Total Labor Force (in %) in Morocco in 2007 to that in 2011?
Keep it short and to the point. 1.07. What is the ratio of the Total Labor Force (in %) in Tanzania in 2007 to that in 2011?
Offer a terse response. 1. What is the ratio of the Total Labor Force (in %) in Bhutan in 2008 to that in 2009?
Provide a succinct answer. 0.99. What is the ratio of the Total Labor Force (in %) of Morocco in 2008 to that in 2009?
Your response must be concise. 1.03. What is the ratio of the Total Labor Force (in %) in Tanzania in 2008 to that in 2009?
Provide a short and direct response. 1. What is the ratio of the Total Labor Force (in %) in Kenya in 2008 to that in 2010?
Keep it short and to the point. 0.99. What is the ratio of the Total Labor Force (in %) of Morocco in 2008 to that in 2010?
Offer a terse response. 1.06. What is the ratio of the Total Labor Force (in %) in Bhutan in 2008 to that in 2011?
Your answer should be compact. 0.99. What is the ratio of the Total Labor Force (in %) of Kenya in 2008 to that in 2011?
Offer a terse response. 0.99. What is the ratio of the Total Labor Force (in %) of Morocco in 2008 to that in 2011?
Offer a terse response. 1.05. What is the ratio of the Total Labor Force (in %) of Bhutan in 2009 to that in 2010?
Provide a short and direct response. 1. What is the ratio of the Total Labor Force (in %) of Morocco in 2009 to that in 2010?
Make the answer very short. 1.03. What is the ratio of the Total Labor Force (in %) in Tanzania in 2009 to that in 2010?
Make the answer very short. 1. What is the ratio of the Total Labor Force (in %) in Morocco in 2009 to that in 2011?
Provide a short and direct response. 1.02. What is the ratio of the Total Labor Force (in %) of Tanzania in 2009 to that in 2011?
Keep it short and to the point. 1. What is the ratio of the Total Labor Force (in %) of Kenya in 2010 to that in 2011?
Keep it short and to the point. 1. What is the difference between the highest and the second highest Total Labor Force (in %) of Kenya?
Provide a succinct answer. 0.3. What is the difference between the highest and the second highest Total Labor Force (in %) of Morocco?
Offer a very short reply. 0.6. What is the difference between the highest and the second highest Total Labor Force (in %) in Tanzania?
Your response must be concise. 0.1. What is the difference between the highest and the lowest Total Labor Force (in %) in Bhutan?
Keep it short and to the point. 5.3. What is the difference between the highest and the lowest Total Labor Force (in %) in Kenya?
Your answer should be very brief. 1.7. What is the difference between the highest and the lowest Total Labor Force (in %) of Morocco?
Give a very brief answer. 3.5. 